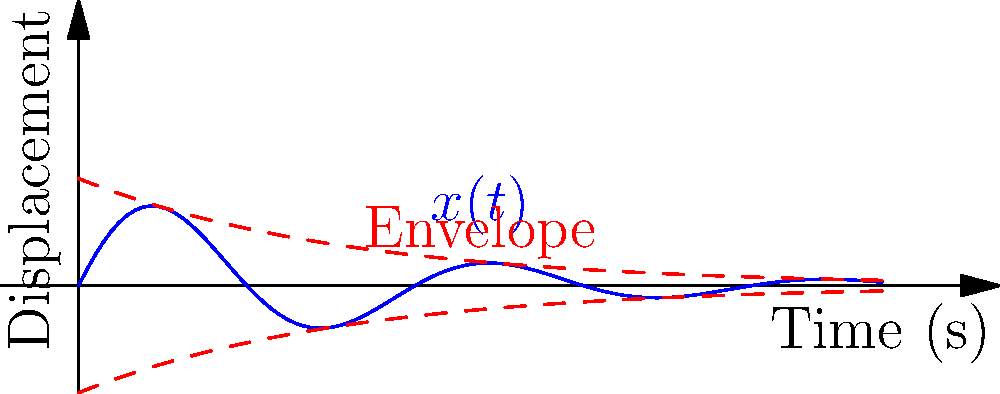Analyze the force-displacement relationship in a spring-mass-damper system under vibration. Given the displacement function $x(t) = 2e^{-0.2t}\sin(t)$, determine the natural frequency $\omega_n$ and damping ratio $\zeta$ of the system. How would you characterize this system's damping? Let's approach this step-by-step:

1) The general form of displacement for an underdamped system is:
   $x(t) = Ae^{-\zeta\omega_n t}\sin(\omega_d t)$

2) Comparing our given function to this general form:
   $x(t) = 2e^{-0.2t}\sin(t)$

3) We can identify:
   $A = 2$
   $\zeta\omega_n = 0.2$
   $\omega_d = 1$ (coefficient of $t$ in $\sin(t)$)

4) For an underdamped system, $\omega_d = \omega_n\sqrt{1-\zeta^2}$

5) We know $\omega_d = 1$, so:
   $1 = \omega_n\sqrt{1-\zeta^2}$

6) From step 3, we have:
   $\zeta\omega_n = 0.2$

7) Squaring both sides of equations from steps 5 and 6:
   $1 = \omega_n^2(1-\zeta^2)$
   $0.04 = \zeta^2\omega_n^2$

8) Adding these equations:
   $1.04 = \omega_n^2$

9) Therefore:
   $\omega_n = \sqrt{1.04} \approx 1.02$ rad/s

10) Substituting back to find $\zeta$:
    $\zeta = 0.2/\omega_n = 0.2/1.02 \approx 0.196$

11) To characterize the damping, we compare $\zeta$ to critical values:
    - $\zeta < 1$: underdamped
    - $\zeta = 1$: critically damped
    - $\zeta > 1$: overdamped

    Since $\zeta \approx 0.196 < 1$, this system is underdamped.
Answer: $\omega_n \approx 1.02$ rad/s, $\zeta \approx 0.196$, underdamped system 